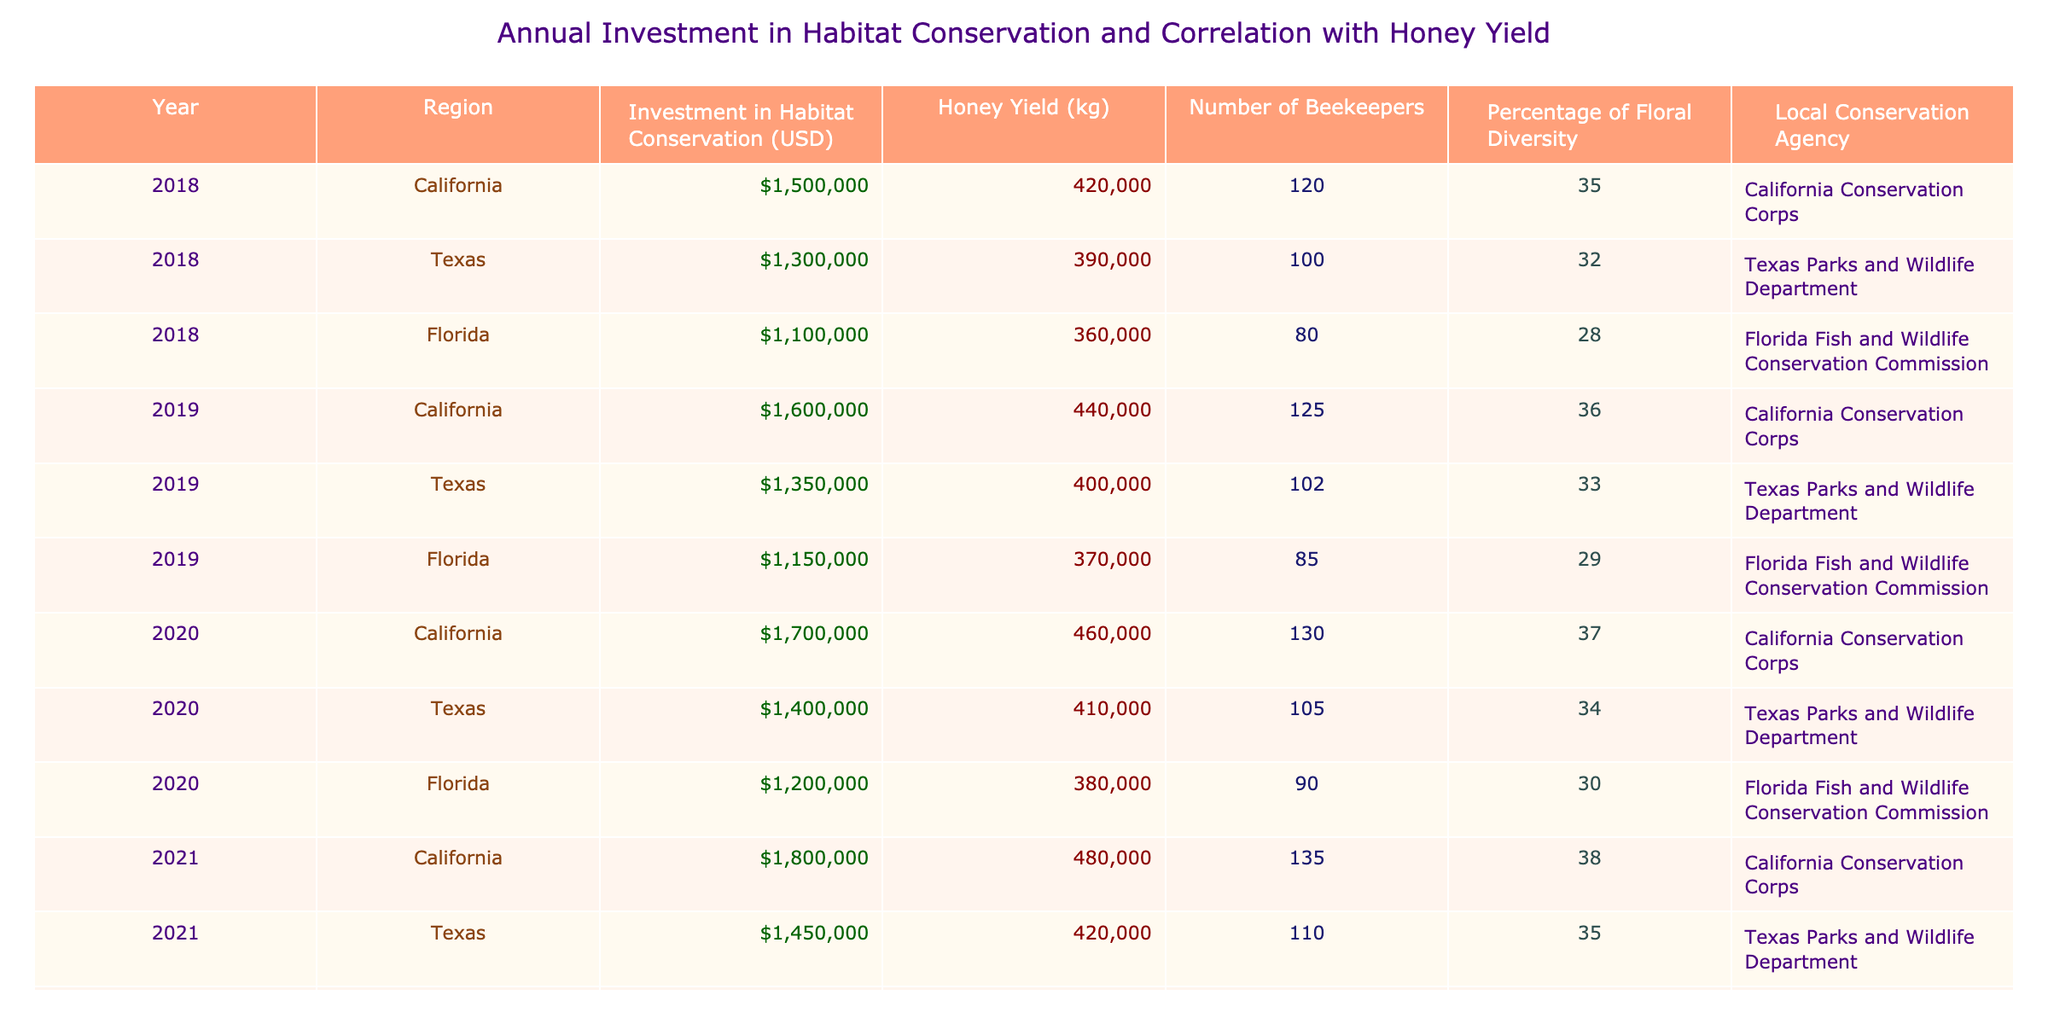What was the honey yield in Florida in 2020? In the table, I can directly look for the row that corresponds to Florida in the year 2020. The value listed under the Honey Yield column for Florida in 2020 is 380,000 kg.
Answer: 380,000 kg Which region had the highest investment in habitat conservation in 2022? In the table, I check the Investment in Habitat Conservation column for the year 2022. California has an investment of 1,900,000 USD, which is greater than Texas (1,500,000 USD) and Florida (1,300,000 USD).
Answer: California What is the total investment in habitat conservation for Texas from 2018 to 2022? I will sum the investments for Texas over the five years: 1,300,000 + 1,350,000 + 1,400,000 + 1,450,000 + 1,500,000 = 7,950,000 USD.
Answer: 7,950,000 USD Did honey yield increase in California every year from 2018 to 2022? By reviewing the Honey Yield data for California from 2018 to 2022, I can see the yields were: 420,000, 440,000, 460,000, 480,000, and 500,000 kg respectively. As each years' value is greater than the previous, yes, the yield consistently increased.
Answer: Yes What is the average percentage of floral diversity in Florida over the years 2018 to 2022? To find the average, I gather the values of floral diversity for Florida: 28, 29, 30, 31, 32. I sum these values: 28 + 29 + 30 + 31 + 32 = 150, and then divide by 5 (the number of entries): 150 / 5 = 30.
Answer: 30 Which local conservation agency is associated with the highest honey yield in 2021? In 2021, California has the highest honey yield of 480,000 kg, and the associated agency is the California Conservation Corps. I find this agency from the corresponding row.
Answer: California Conservation Corps What is the difference in honey yield between Florida in 2019 and Florida in 2022? I first look up the honey yields: Florida in 2019 has 370,000 kg and Florida in 2022 has 400,000 kg. I calculate the difference: 400,000 - 370,000 = 30,000 kg.
Answer: 30,000 kg Was the number of beekeepers in Texas higher than in California in 2021? I look at the Number of Beekeepers column for Texas (110) and California (135) in 2021. Since 110 is not higher than 135, the statement is false.
Answer: No 